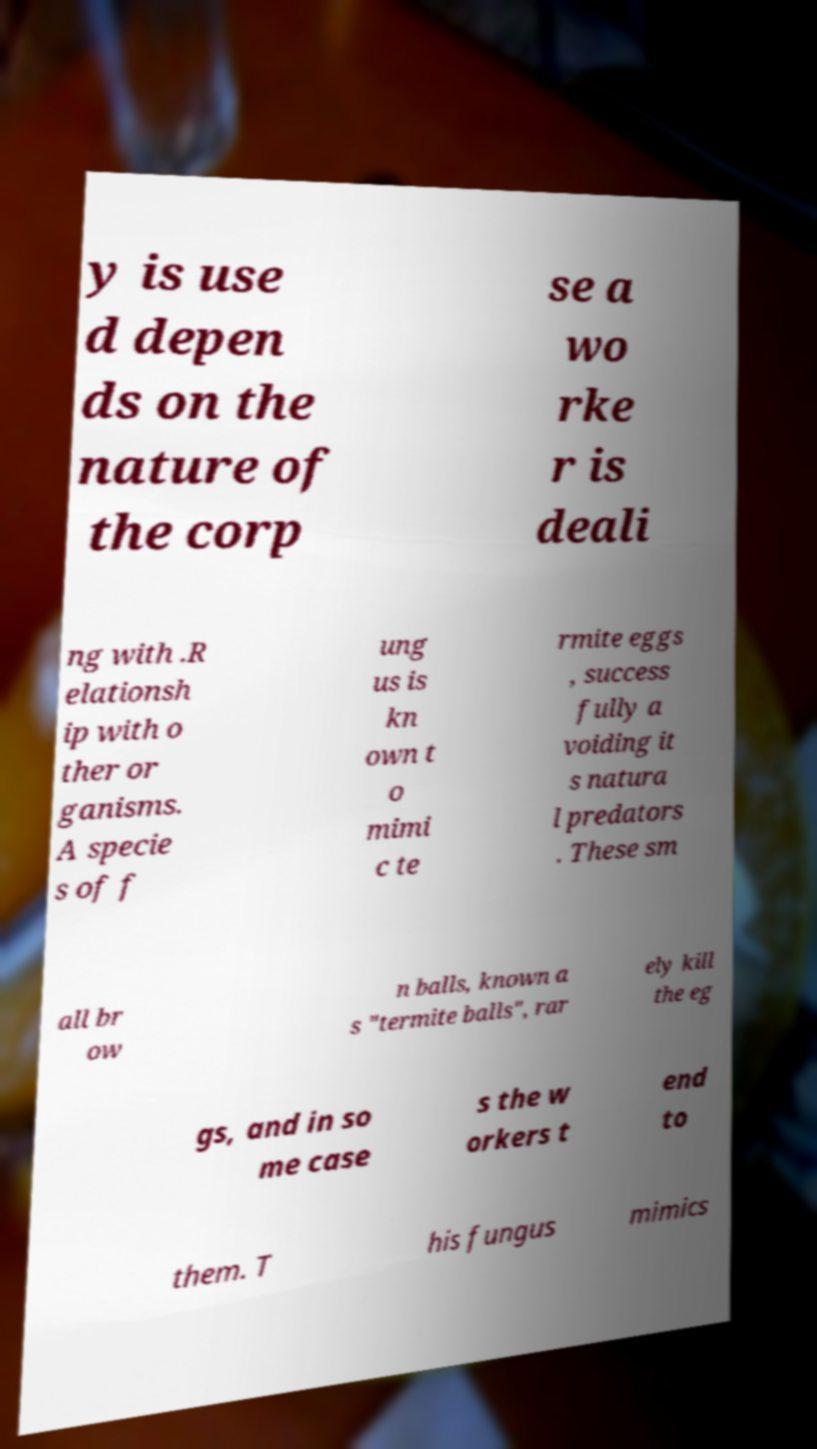What messages or text are displayed in this image? I need them in a readable, typed format. y is use d depen ds on the nature of the corp se a wo rke r is deali ng with .R elationsh ip with o ther or ganisms. A specie s of f ung us is kn own t o mimi c te rmite eggs , success fully a voiding it s natura l predators . These sm all br ow n balls, known a s "termite balls", rar ely kill the eg gs, and in so me case s the w orkers t end to them. T his fungus mimics 